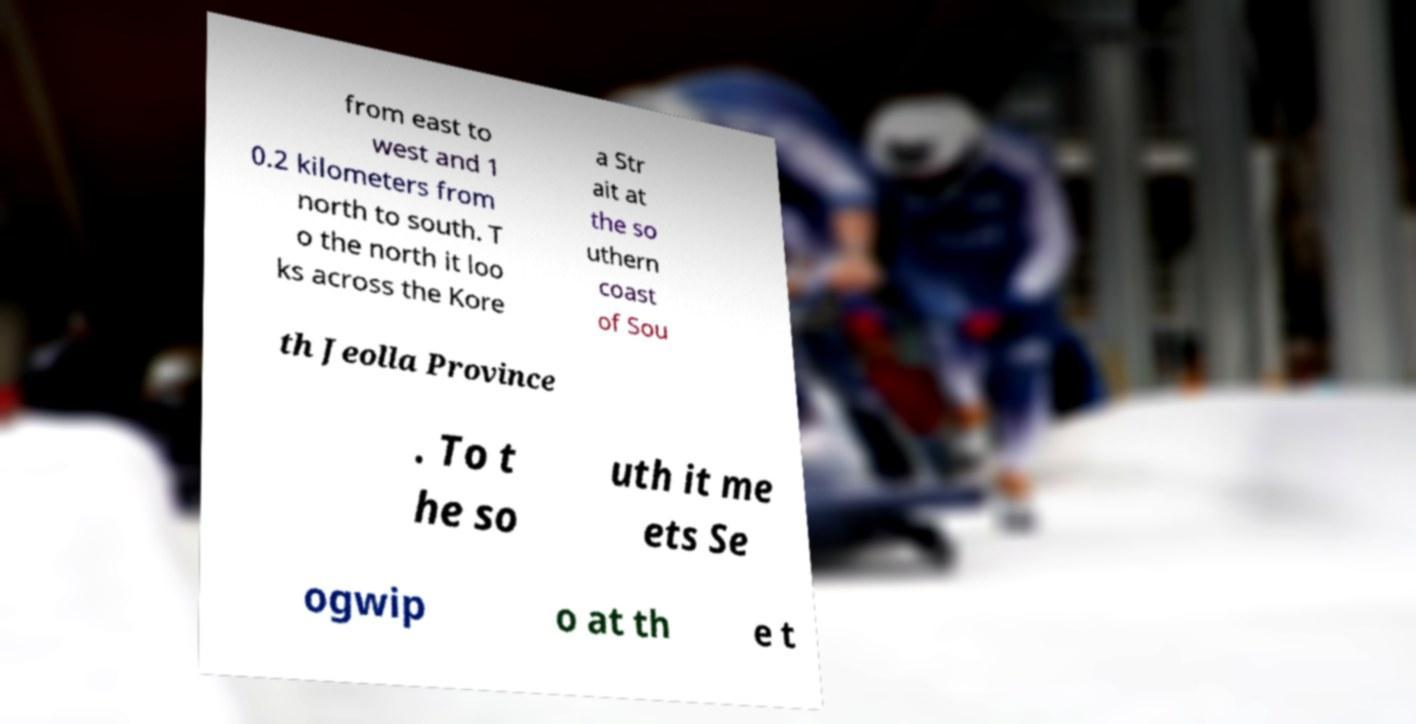There's text embedded in this image that I need extracted. Can you transcribe it verbatim? from east to west and 1 0.2 kilometers from north to south. T o the north it loo ks across the Kore a Str ait at the so uthern coast of Sou th Jeolla Province . To t he so uth it me ets Se ogwip o at th e t 